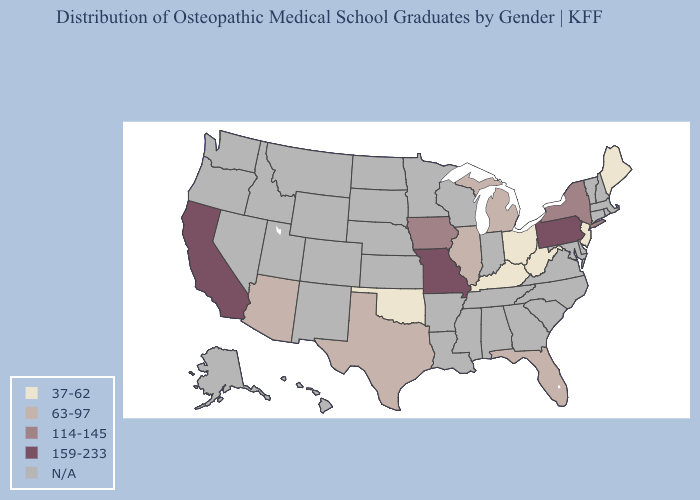Name the states that have a value in the range 159-233?
Be succinct. California, Missouri, Pennsylvania. What is the highest value in the West ?
Quick response, please. 159-233. Which states have the highest value in the USA?
Give a very brief answer. California, Missouri, Pennsylvania. Name the states that have a value in the range 37-62?
Short answer required. Kentucky, Maine, New Jersey, Ohio, Oklahoma, West Virginia. Name the states that have a value in the range 63-97?
Write a very short answer. Arizona, Florida, Illinois, Michigan, Texas. Name the states that have a value in the range 159-233?
Answer briefly. California, Missouri, Pennsylvania. Which states have the highest value in the USA?
Be succinct. California, Missouri, Pennsylvania. Which states have the lowest value in the USA?
Quick response, please. Kentucky, Maine, New Jersey, Ohio, Oklahoma, West Virginia. How many symbols are there in the legend?
Short answer required. 5. Among the states that border Indiana , does Kentucky have the lowest value?
Be succinct. Yes. Which states hav the highest value in the MidWest?
Be succinct. Missouri. 